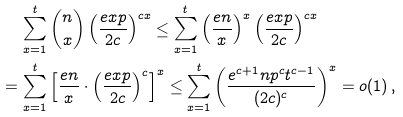Convert formula to latex. <formula><loc_0><loc_0><loc_500><loc_500>& \, \sum _ { x = 1 } ^ { t } \binom { n } { x } \left ( \frac { e x p } { 2 c } \right ) ^ { c x } \leq \sum _ { x = 1 } ^ { t } \left ( \frac { e n } { x } \right ) ^ { x } \left ( \frac { e x p } { 2 c } \right ) ^ { c x } \\ = & \, \sum _ { x = 1 } ^ { t } \left [ \frac { e n } { x } \cdot \left ( \frac { e x p } { 2 c } \right ) ^ { c } \right ] ^ { x } \leq \sum _ { x = 1 } ^ { t } \left ( \frac { e ^ { c + 1 } n p ^ { c } t ^ { c - 1 } } { ( 2 c ) ^ { c } } \right ) ^ { x } = o ( 1 ) \, ,</formula> 